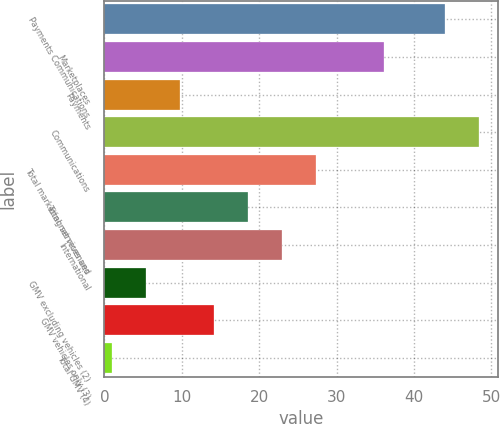Convert chart. <chart><loc_0><loc_0><loc_500><loc_500><bar_chart><fcel>Payments Communications<fcel>Marketplaces<fcel>Payments<fcel>Communications<fcel>Total marketing services and<fcel>Total net revenues<fcel>International<fcel>GMV excluding vehicles (2)<fcel>GMV vehicles only (3)<fcel>Total GMV (4)<nl><fcel>44<fcel>36.2<fcel>9.8<fcel>48.4<fcel>27.4<fcel>18.6<fcel>23<fcel>5.4<fcel>14.2<fcel>1<nl></chart> 